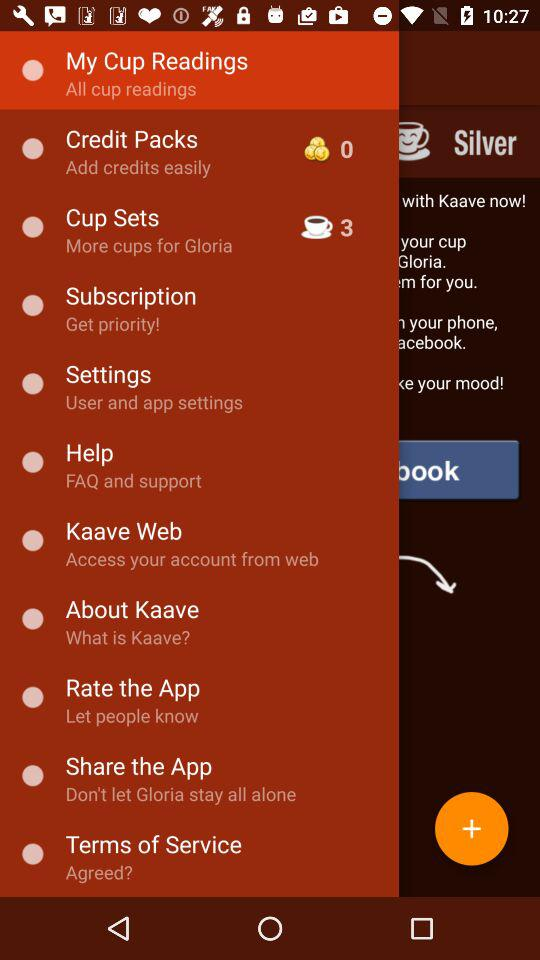How many coins are in the credit packs? There are 0 coins. 